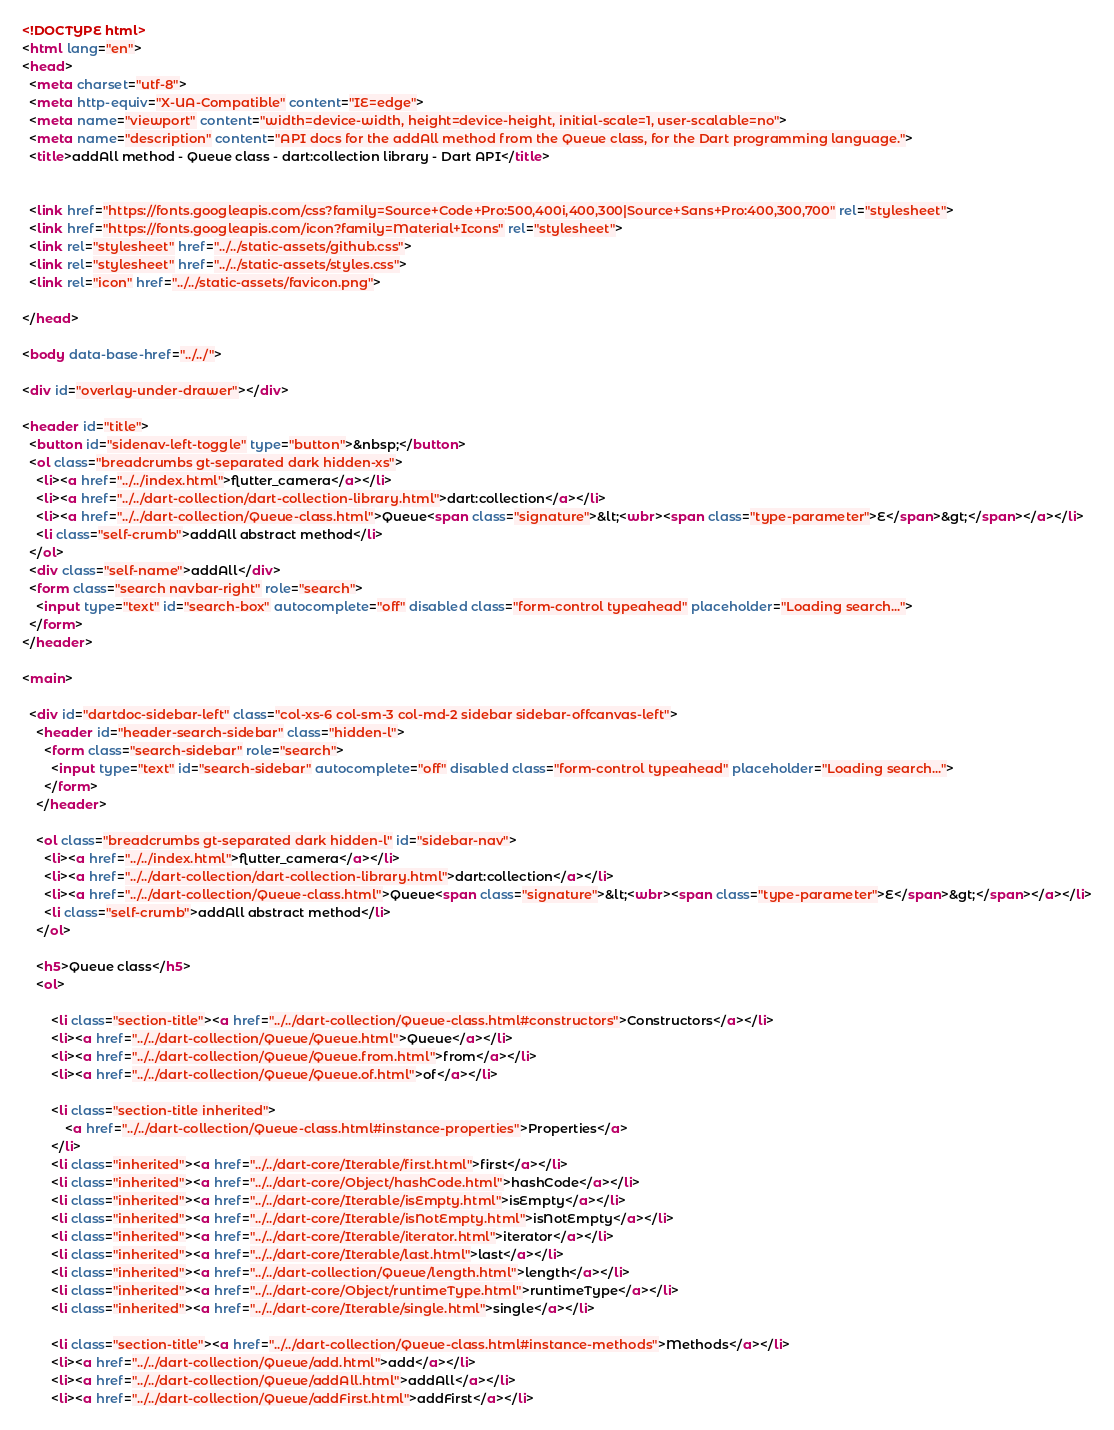Convert code to text. <code><loc_0><loc_0><loc_500><loc_500><_HTML_><!DOCTYPE html>
<html lang="en">
<head>
  <meta charset="utf-8">
  <meta http-equiv="X-UA-Compatible" content="IE=edge">
  <meta name="viewport" content="width=device-width, height=device-height, initial-scale=1, user-scalable=no">
  <meta name="description" content="API docs for the addAll method from the Queue class, for the Dart programming language.">
  <title>addAll method - Queue class - dart:collection library - Dart API</title>

  
  <link href="https://fonts.googleapis.com/css?family=Source+Code+Pro:500,400i,400,300|Source+Sans+Pro:400,300,700" rel="stylesheet">
  <link href="https://fonts.googleapis.com/icon?family=Material+Icons" rel="stylesheet">
  <link rel="stylesheet" href="../../static-assets/github.css">
  <link rel="stylesheet" href="../../static-assets/styles.css">
  <link rel="icon" href="../../static-assets/favicon.png">

</head>

<body data-base-href="../../">

<div id="overlay-under-drawer"></div>

<header id="title">
  <button id="sidenav-left-toggle" type="button">&nbsp;</button>
  <ol class="breadcrumbs gt-separated dark hidden-xs">
    <li><a href="../../index.html">flutter_camera</a></li>
    <li><a href="../../dart-collection/dart-collection-library.html">dart:collection</a></li>
    <li><a href="../../dart-collection/Queue-class.html">Queue<span class="signature">&lt;<wbr><span class="type-parameter">E</span>&gt;</span></a></li>
    <li class="self-crumb">addAll abstract method</li>
  </ol>
  <div class="self-name">addAll</div>
  <form class="search navbar-right" role="search">
    <input type="text" id="search-box" autocomplete="off" disabled class="form-control typeahead" placeholder="Loading search...">
  </form>
</header>

<main>

  <div id="dartdoc-sidebar-left" class="col-xs-6 col-sm-3 col-md-2 sidebar sidebar-offcanvas-left">
    <header id="header-search-sidebar" class="hidden-l">
      <form class="search-sidebar" role="search">
        <input type="text" id="search-sidebar" autocomplete="off" disabled class="form-control typeahead" placeholder="Loading search...">
      </form>
    </header>
    
    <ol class="breadcrumbs gt-separated dark hidden-l" id="sidebar-nav">
      <li><a href="../../index.html">flutter_camera</a></li>
      <li><a href="../../dart-collection/dart-collection-library.html">dart:collection</a></li>
      <li><a href="../../dart-collection/Queue-class.html">Queue<span class="signature">&lt;<wbr><span class="type-parameter">E</span>&gt;</span></a></li>
      <li class="self-crumb">addAll abstract method</li>
    </ol>
    
    <h5>Queue class</h5>
    <ol>
    
        <li class="section-title"><a href="../../dart-collection/Queue-class.html#constructors">Constructors</a></li>
        <li><a href="../../dart-collection/Queue/Queue.html">Queue</a></li>
        <li><a href="../../dart-collection/Queue/Queue.from.html">from</a></li>
        <li><a href="../../dart-collection/Queue/Queue.of.html">of</a></li>
    
        <li class="section-title inherited">
            <a href="../../dart-collection/Queue-class.html#instance-properties">Properties</a>
        </li>
        <li class="inherited"><a href="../../dart-core/Iterable/first.html">first</a></li>
        <li class="inherited"><a href="../../dart-core/Object/hashCode.html">hashCode</a></li>
        <li class="inherited"><a href="../../dart-core/Iterable/isEmpty.html">isEmpty</a></li>
        <li class="inherited"><a href="../../dart-core/Iterable/isNotEmpty.html">isNotEmpty</a></li>
        <li class="inherited"><a href="../../dart-core/Iterable/iterator.html">iterator</a></li>
        <li class="inherited"><a href="../../dart-core/Iterable/last.html">last</a></li>
        <li class="inherited"><a href="../../dart-collection/Queue/length.html">length</a></li>
        <li class="inherited"><a href="../../dart-core/Object/runtimeType.html">runtimeType</a></li>
        <li class="inherited"><a href="../../dart-core/Iterable/single.html">single</a></li>
    
        <li class="section-title"><a href="../../dart-collection/Queue-class.html#instance-methods">Methods</a></li>
        <li><a href="../../dart-collection/Queue/add.html">add</a></li>
        <li><a href="../../dart-collection/Queue/addAll.html">addAll</a></li>
        <li><a href="../../dart-collection/Queue/addFirst.html">addFirst</a></li></code> 